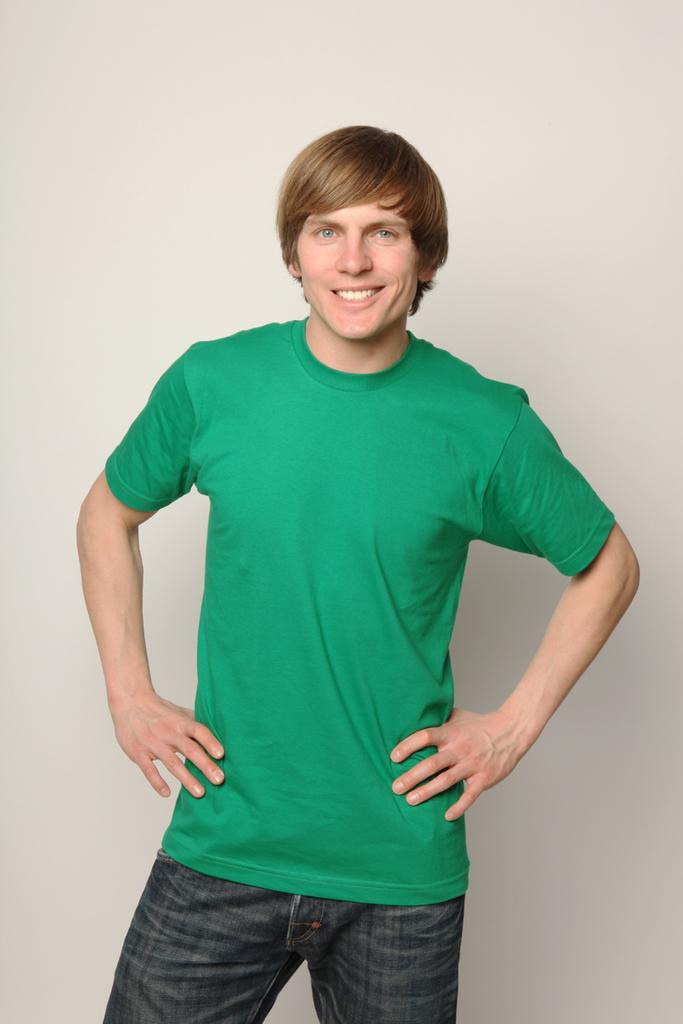What is the main subject of the image? There is a person standing in the center of the image. What is the person's expression in the image? The person is smiling. What can be seen in the background of the image? There is a wall in the background of the image. What is the person's opinion on the family in the image? There is no family present in the image, so it is not possible to determine the person's opinion on them. 